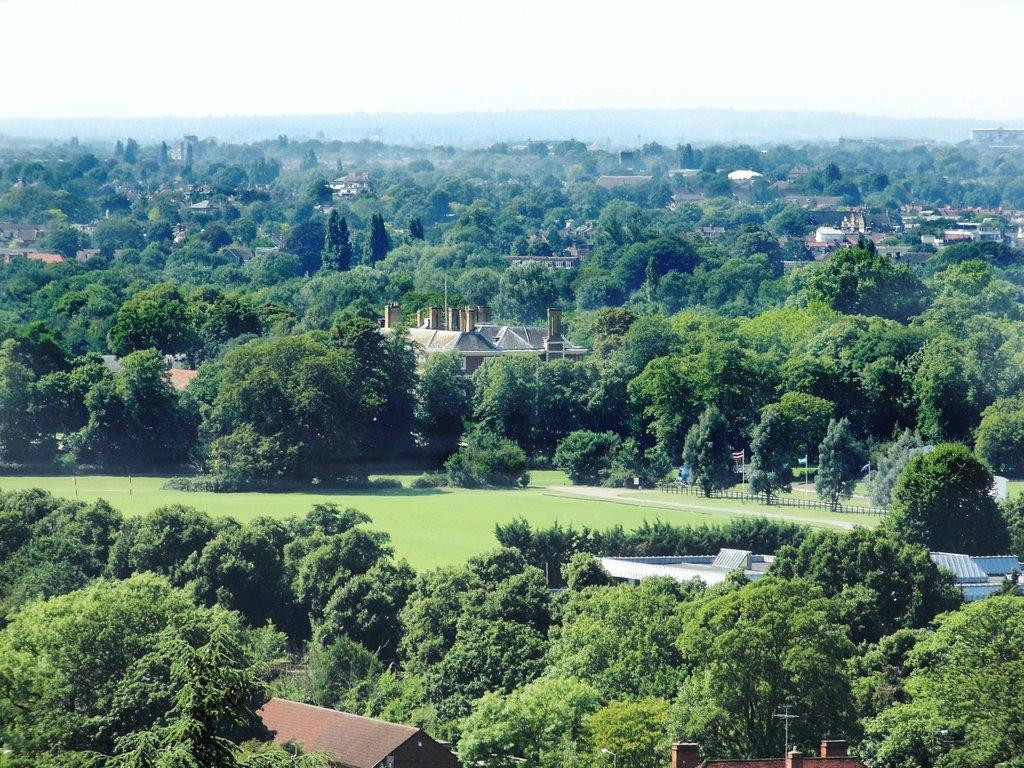What can be seen in the background of the image? There are buildings, trees, and the sky visible in the background of the image. What type of barrier is present in the image? There is a fence in the image. What type of vegetation is present in the image? There is grass in the image. What additional objects can be seen in the image? There are flags in the image. Can you tell me how many mittens are being worn by the daughter in the image? There is no daughter or mittens present in the image. What type of slope can be seen in the image? There is no slope present in the image. 